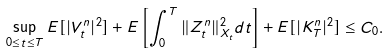Convert formula to latex. <formula><loc_0><loc_0><loc_500><loc_500>\sup _ { 0 \leq t \leq T } E [ | V _ { t } ^ { n } | ^ { 2 } ] + E \left [ \int _ { 0 } ^ { T } \| Z _ { t } ^ { n } \| ^ { 2 } _ { X _ { t } } d t \right ] + E [ | K _ { T } ^ { n } | ^ { 2 } ] \leq C _ { 0 } .</formula> 